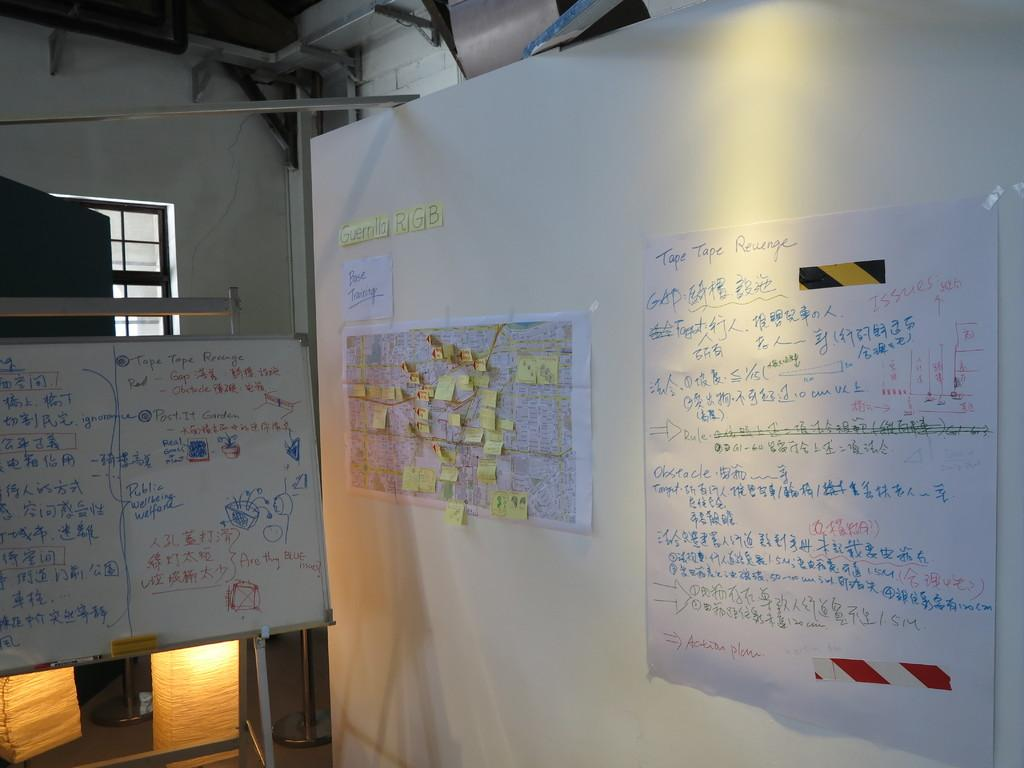<image>
Present a compact description of the photo's key features. A white board and posters on the wall make up a plan for Tape Tape Revenge. 